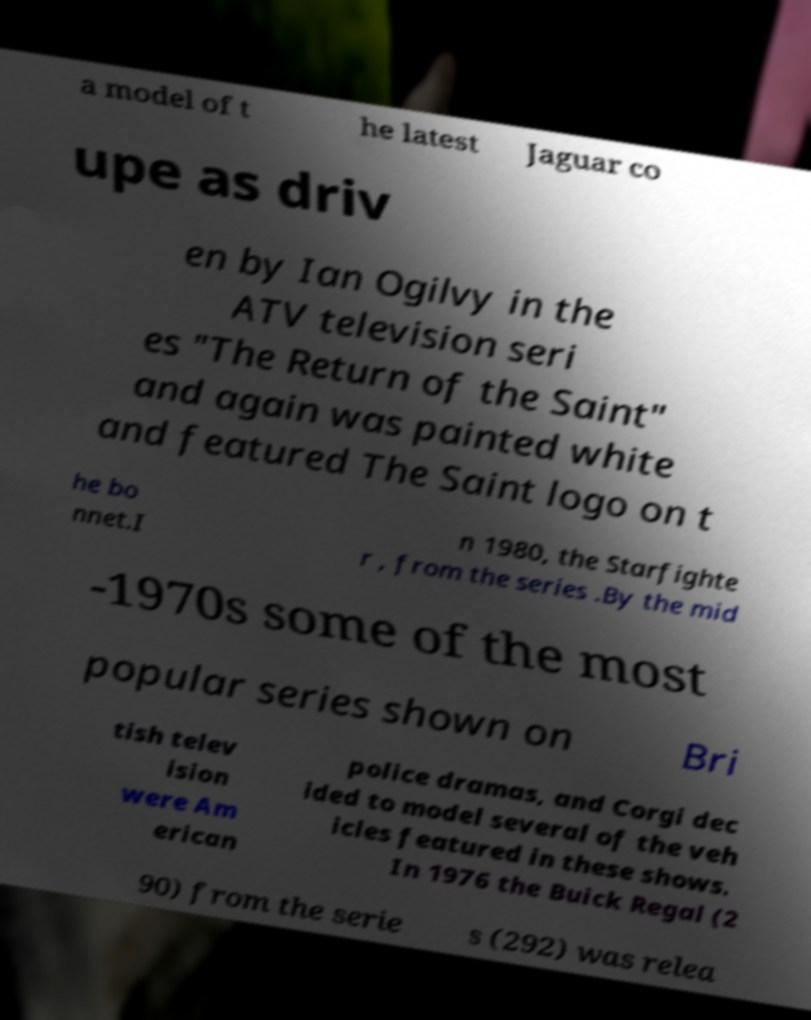I need the written content from this picture converted into text. Can you do that? a model of t he latest Jaguar co upe as driv en by Ian Ogilvy in the ATV television seri es "The Return of the Saint" and again was painted white and featured The Saint logo on t he bo nnet.I n 1980, the Starfighte r , from the series .By the mid -1970s some of the most popular series shown on Bri tish telev ision were Am erican police dramas, and Corgi dec ided to model several of the veh icles featured in these shows. In 1976 the Buick Regal (2 90) from the serie s (292) was relea 